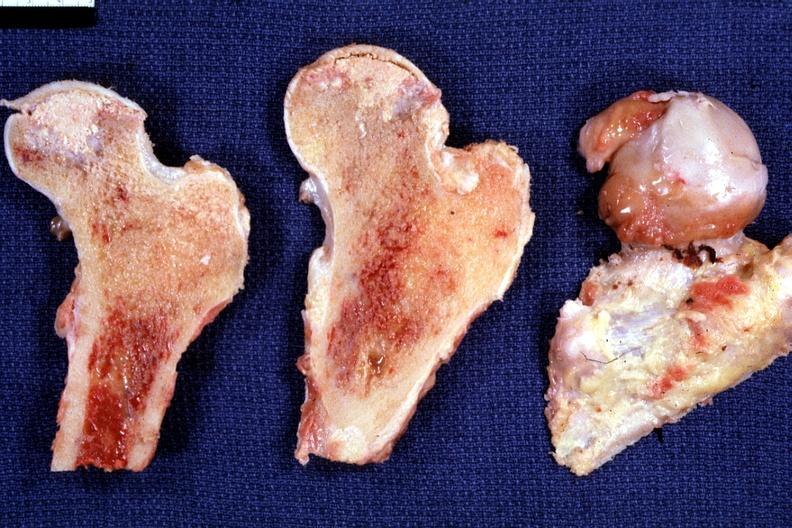does this image show fixed tissue nice photo showing focal osteonecrosis in the femoral head?
Answer the question using a single word or phrase. Yes 